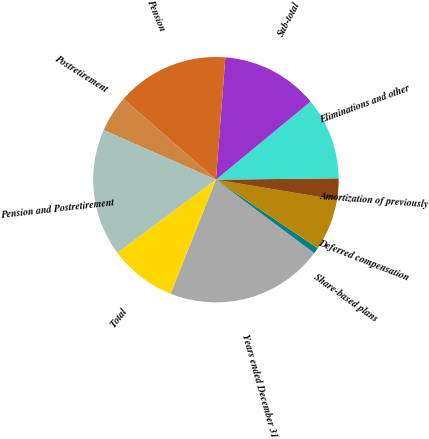<chart> <loc_0><loc_0><loc_500><loc_500><pie_chart><fcel>Years ended December 31<fcel>Share-based plans<fcel>Deferred compensation<fcel>Amortization of previously<fcel>Eliminations and other<fcel>Sub-total<fcel>Pension<fcel>Postretirement<fcel>Pension and Postretirement<fcel>Total<nl><fcel>20.81%<fcel>0.79%<fcel>6.8%<fcel>2.8%<fcel>10.8%<fcel>12.8%<fcel>14.8%<fcel>4.8%<fcel>16.8%<fcel>8.8%<nl></chart> 